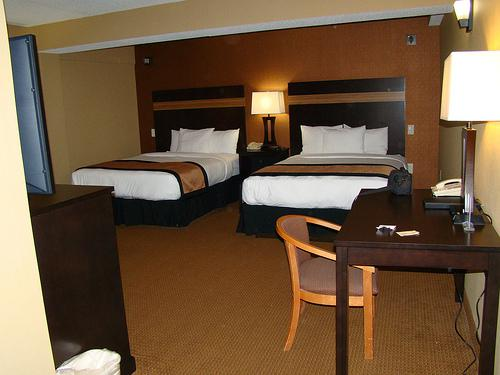Question: where was this picture taken?
Choices:
A. In an office building.
B. In a hotel room.
C. In an apartment building.
D. In a house.
Answer with the letter. Answer: B Question: how many beds are there?
Choices:
A. Three.
B. Four.
C. Two.
D. Seven.
Answer with the letter. Answer: C Question: where is the second table lamp?
Choices:
A. Next to the bed.
B. Next to the couch.
C. Between the beds.
D. Next to the door.
Answer with the letter. Answer: C 